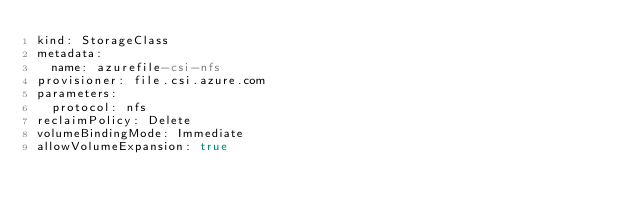Convert code to text. <code><loc_0><loc_0><loc_500><loc_500><_YAML_>kind: StorageClass
metadata:
  name: azurefile-csi-nfs
provisioner: file.csi.azure.com
parameters:
  protocol: nfs
reclaimPolicy: Delete
volumeBindingMode: Immediate
allowVolumeExpansion: true
</code> 